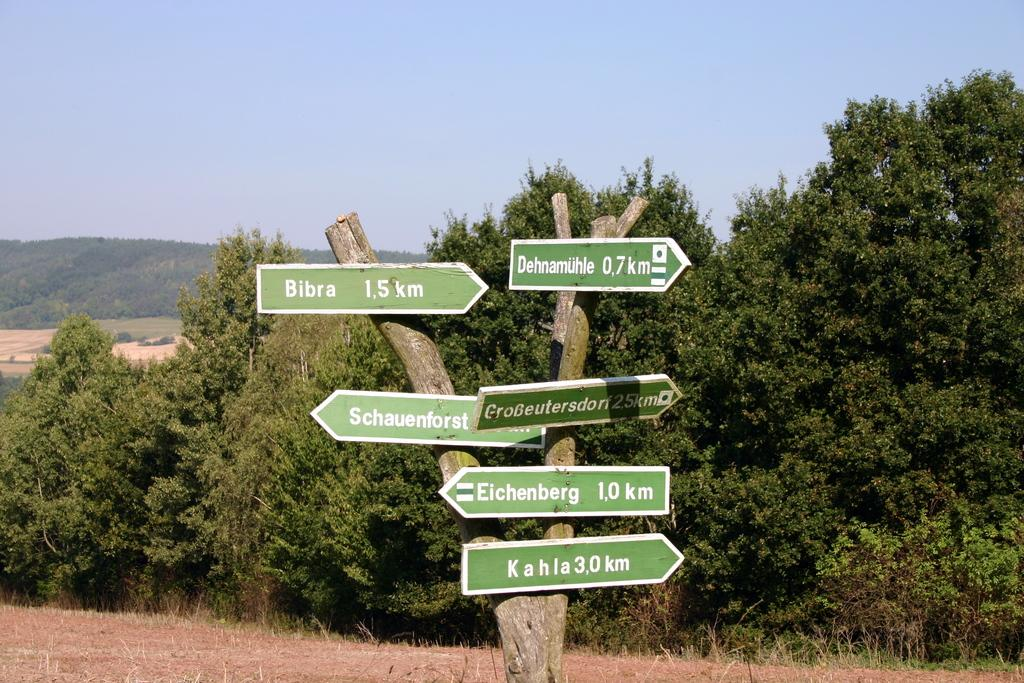<image>
Present a compact description of the photo's key features. According to the sign, Bibra is to the right 1.5 km away. 